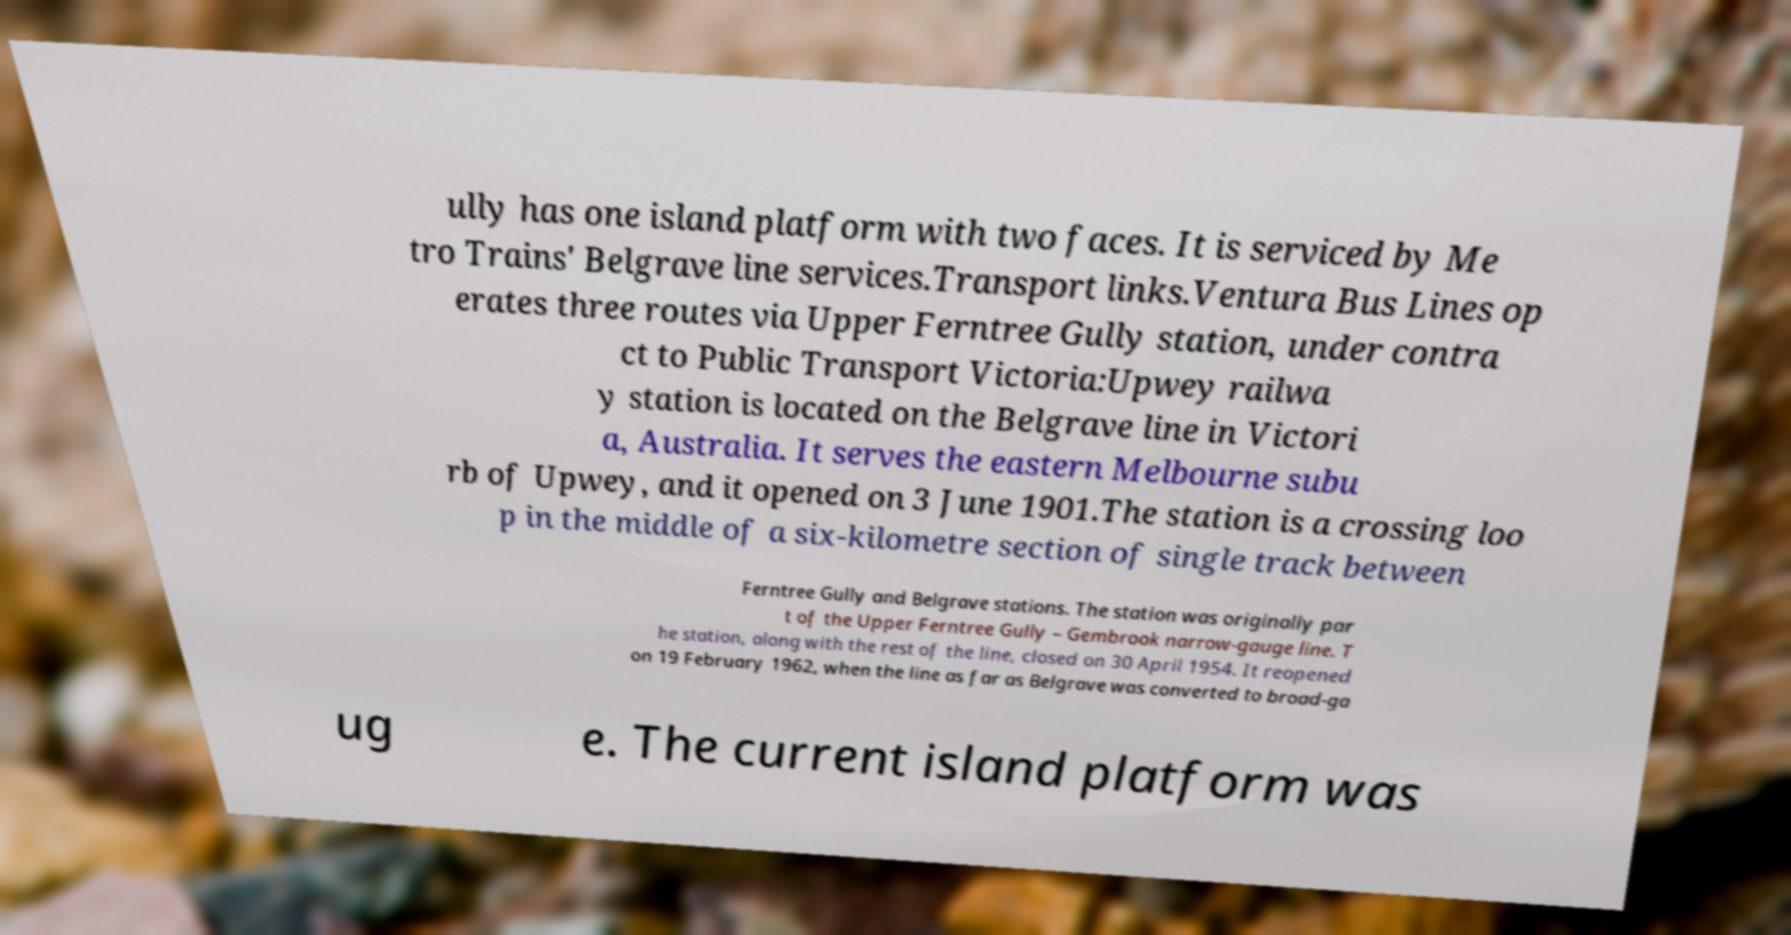Could you extract and type out the text from this image? ully has one island platform with two faces. It is serviced by Me tro Trains' Belgrave line services.Transport links.Ventura Bus Lines op erates three routes via Upper Ferntree Gully station, under contra ct to Public Transport Victoria:Upwey railwa y station is located on the Belgrave line in Victori a, Australia. It serves the eastern Melbourne subu rb of Upwey, and it opened on 3 June 1901.The station is a crossing loo p in the middle of a six-kilometre section of single track between Ferntree Gully and Belgrave stations. The station was originally par t of the Upper Ferntree Gully – Gembrook narrow-gauge line. T he station, along with the rest of the line, closed on 30 April 1954. It reopened on 19 February 1962, when the line as far as Belgrave was converted to broad-ga ug e. The current island platform was 